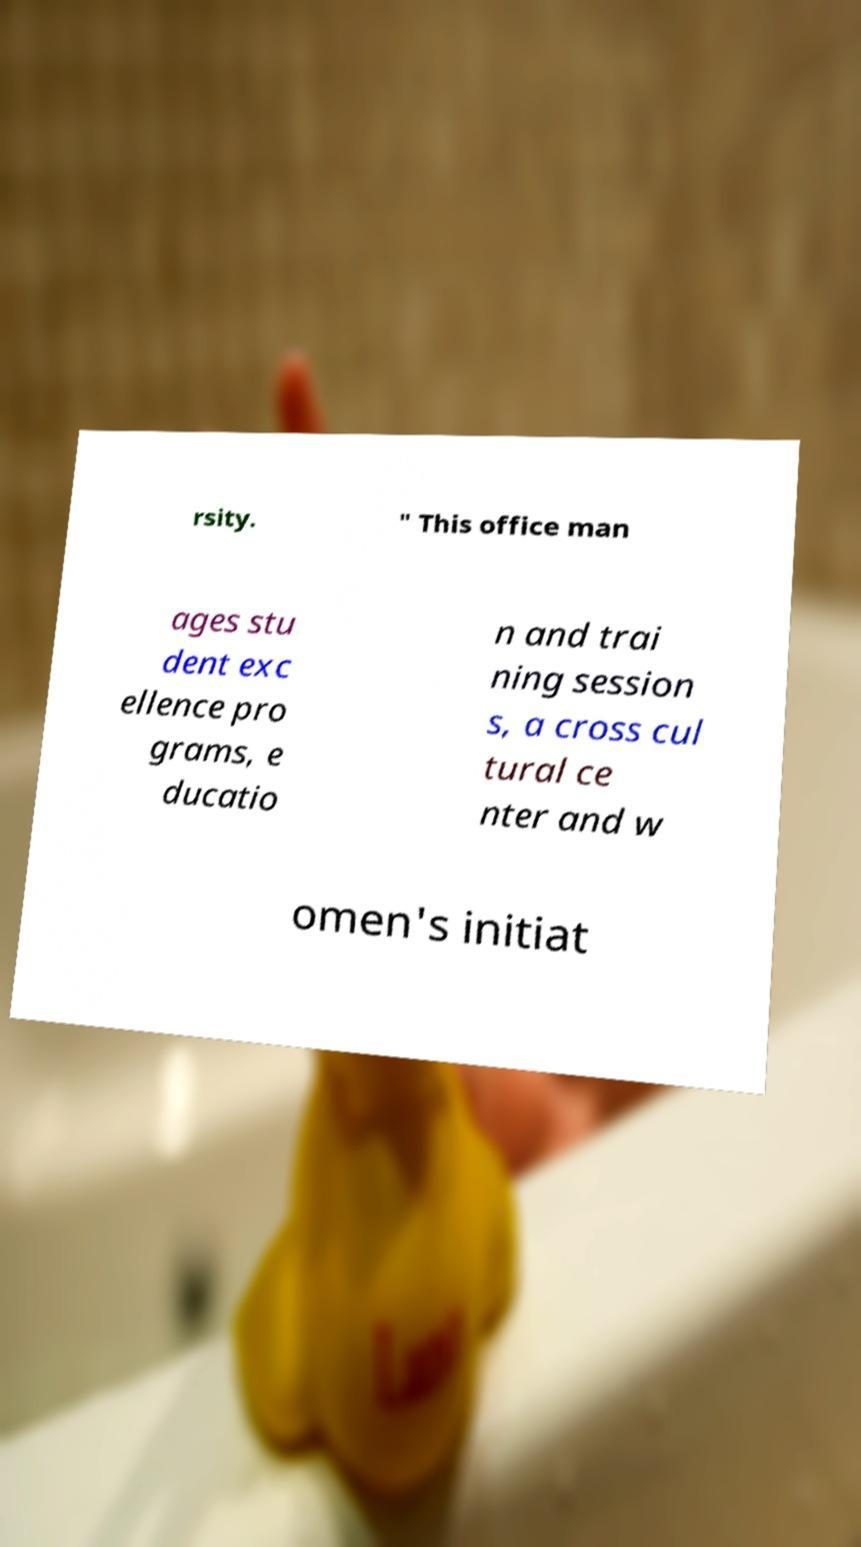There's text embedded in this image that I need extracted. Can you transcribe it verbatim? rsity. " This office man ages stu dent exc ellence pro grams, e ducatio n and trai ning session s, a cross cul tural ce nter and w omen's initiat 